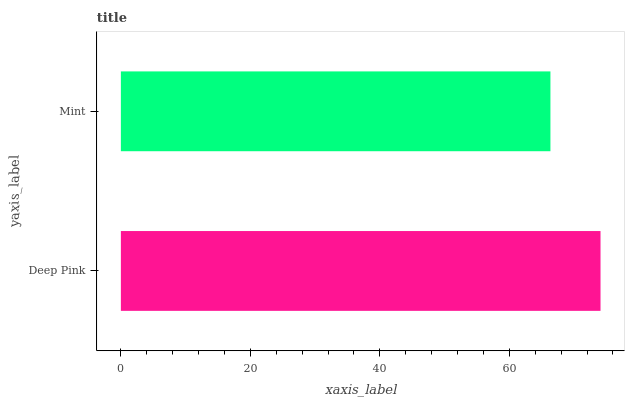Is Mint the minimum?
Answer yes or no. Yes. Is Deep Pink the maximum?
Answer yes or no. Yes. Is Mint the maximum?
Answer yes or no. No. Is Deep Pink greater than Mint?
Answer yes or no. Yes. Is Mint less than Deep Pink?
Answer yes or no. Yes. Is Mint greater than Deep Pink?
Answer yes or no. No. Is Deep Pink less than Mint?
Answer yes or no. No. Is Deep Pink the high median?
Answer yes or no. Yes. Is Mint the low median?
Answer yes or no. Yes. Is Mint the high median?
Answer yes or no. No. Is Deep Pink the low median?
Answer yes or no. No. 